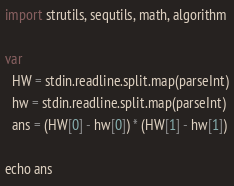Convert code to text. <code><loc_0><loc_0><loc_500><loc_500><_Nim_>import strutils, sequtils, math, algorithm

var
  HW = stdin.readline.split.map(parseInt)
  hw = stdin.readline.split.map(parseInt)
  ans = (HW[0] - hw[0]) * (HW[1] - hw[1])

echo ans</code> 